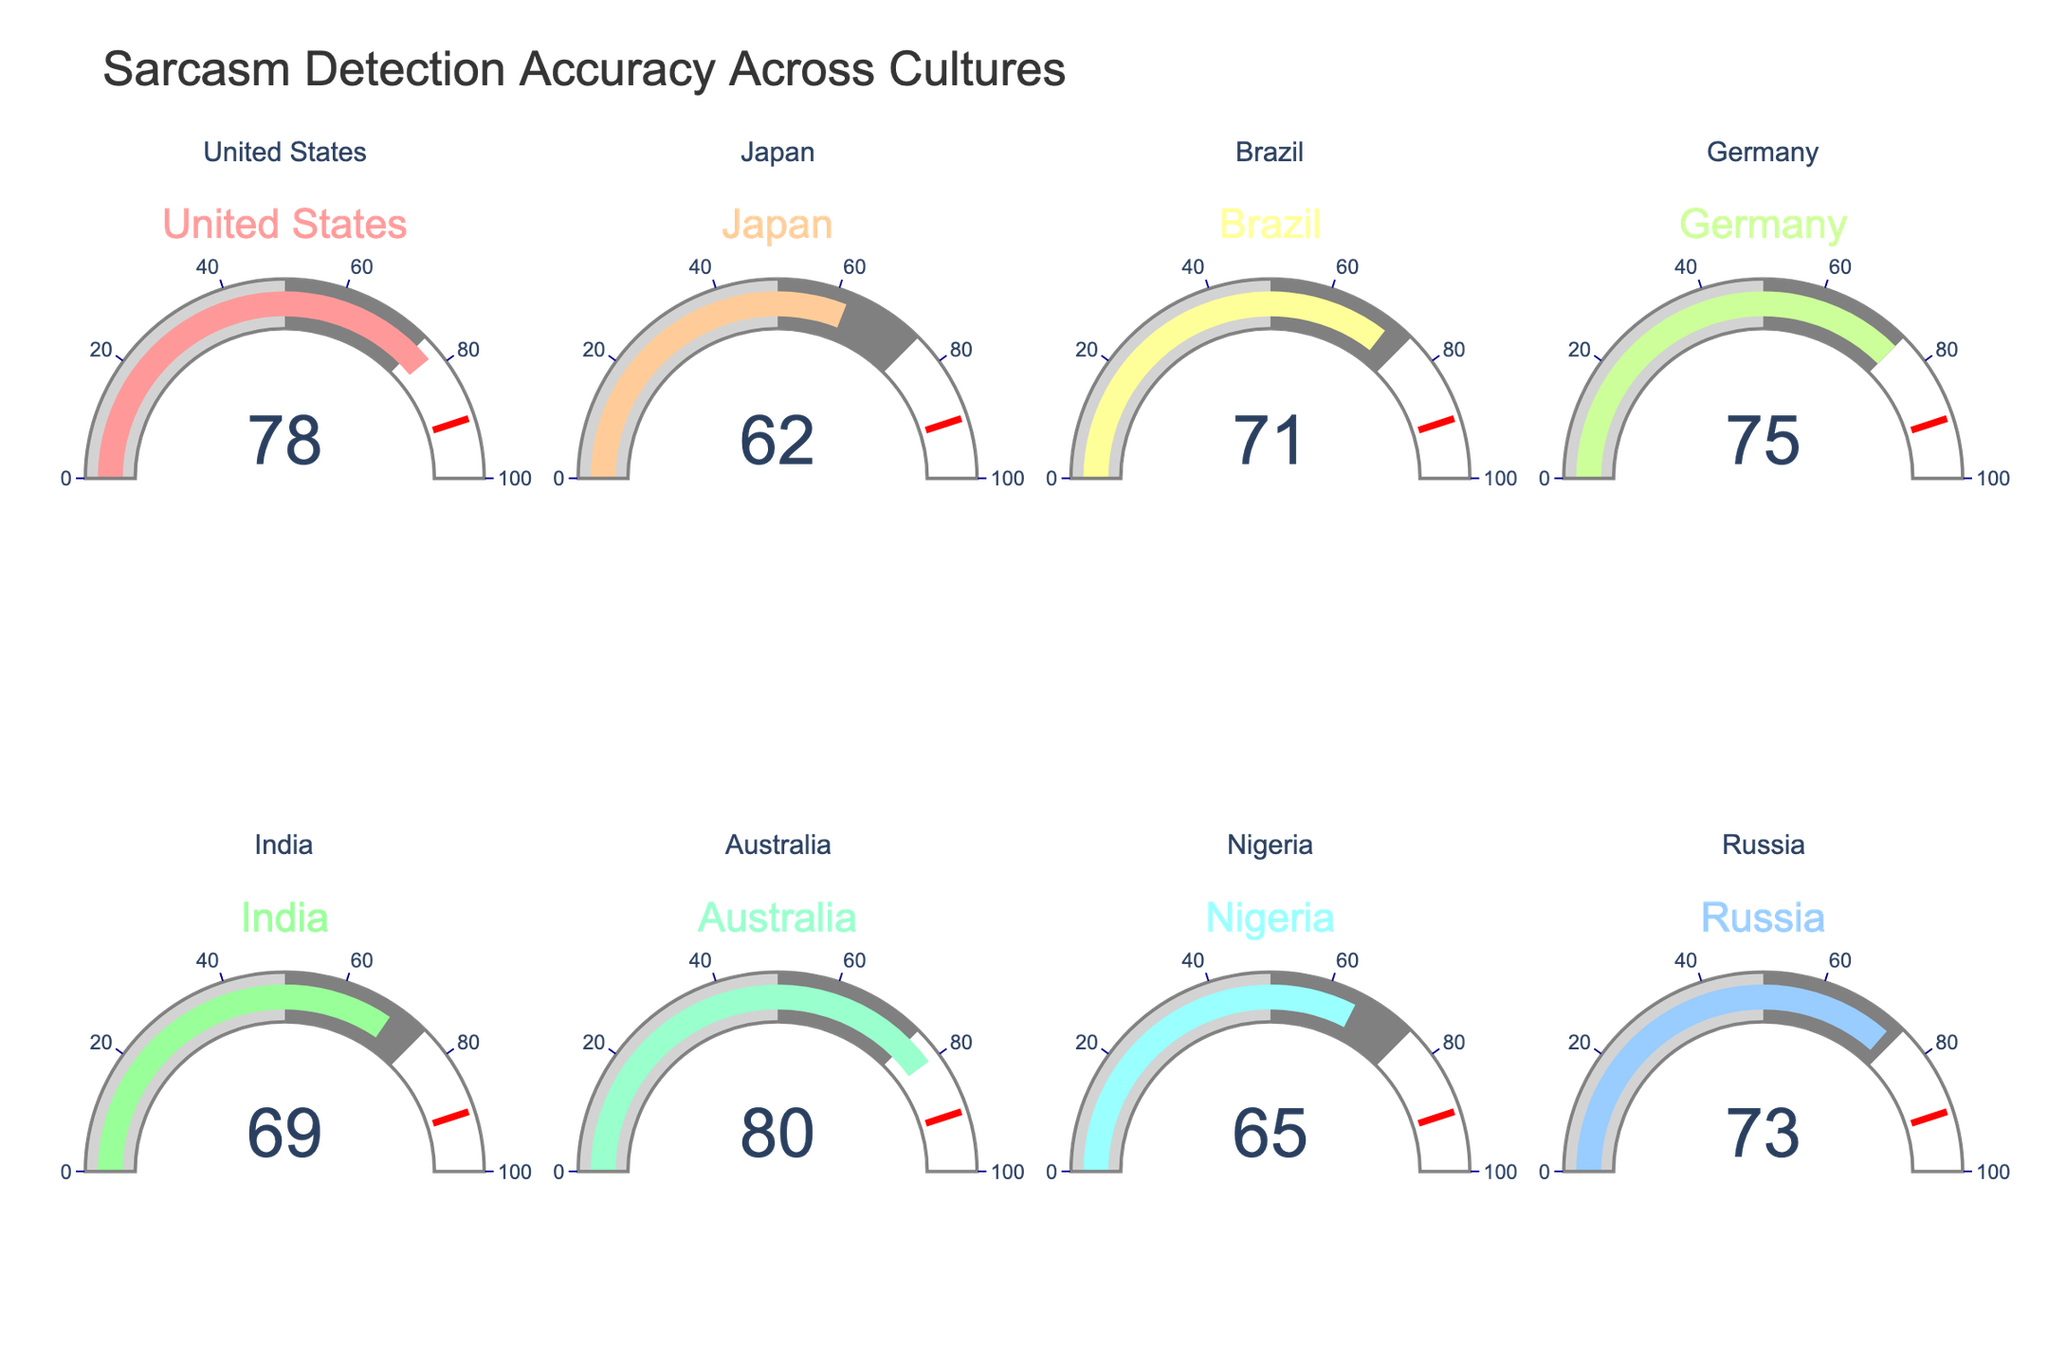What is the sarcasm detection accuracy for Australia? The gauge chart representing Australia shows 80 as the value.
Answer: 80 Which country has the highest sarcasm detection accuracy? By comparing the values on all gauges, the highest value is 80 for Australia.
Answer: Australia Which country has the lowest sarcasm detection accuracy? By comparing the values on all gauges, the lowest value is 62 for Japan.
Answer: Japan What is the average sarcasm detection accuracy across all countries? Sum the accuracies and divide by the number of countries: (78 + 62 + 71 + 75 + 69 + 80 + 65 + 73) / 8 = 573 / 8 = 71.625
Answer: 71.625 How does the sarcasm detection accuracy in Brazil compare to that in Russia? The gauge for Brazil shows 71, and the gauge for Russia shows 73; Brazil's value is less than Russia's.
Answer: Brazil is lower What is the range of sarcasm detection accuracy across the countries? The highest value is 80 (Australia) and the lowest is 62 (Japan), so the range is 80 - 62 = 18.
Answer: 18 If a country had a detection accuracy of 76, which group would it fall in (above or below the average of the given countries)? The average sarcasm detection accuracy is 71.625. A value of 76 is above 71.625.
Answer: Above Find the median sarcasm detection accuracy of the countries presented. Arrange the values in order (62, 65, 69, 71, 73, 75, 78, 80). The median is the average of the two middle values: (71 + 73) / 2 = 72.
Answer: 72 Which countries have a sarcasm detection accuracy below 70? The gauges showing values below 70 are Japan (62), India (69), and Nigeria (65).
Answer: Japan, India, Nigeria What is the difference in sarcasm detection accuracy between the United States and Germany? The United States has an accuracy of 78, and Germany has an accuracy of 75. The difference is 78 - 75 = 3.
Answer: 3 